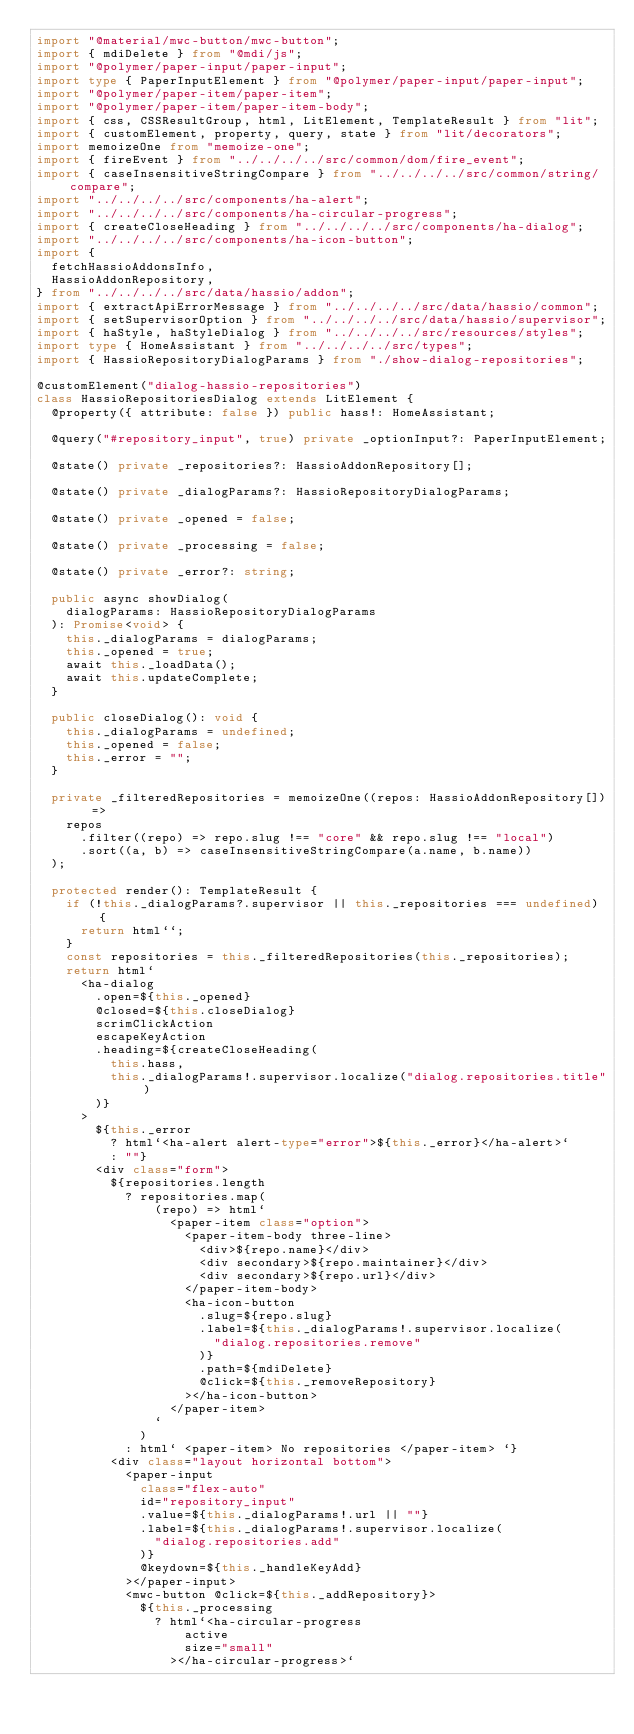Convert code to text. <code><loc_0><loc_0><loc_500><loc_500><_TypeScript_>import "@material/mwc-button/mwc-button";
import { mdiDelete } from "@mdi/js";
import "@polymer/paper-input/paper-input";
import type { PaperInputElement } from "@polymer/paper-input/paper-input";
import "@polymer/paper-item/paper-item";
import "@polymer/paper-item/paper-item-body";
import { css, CSSResultGroup, html, LitElement, TemplateResult } from "lit";
import { customElement, property, query, state } from "lit/decorators";
import memoizeOne from "memoize-one";
import { fireEvent } from "../../../../src/common/dom/fire_event";
import { caseInsensitiveStringCompare } from "../../../../src/common/string/compare";
import "../../../../src/components/ha-alert";
import "../../../../src/components/ha-circular-progress";
import { createCloseHeading } from "../../../../src/components/ha-dialog";
import "../../../../src/components/ha-icon-button";
import {
  fetchHassioAddonsInfo,
  HassioAddonRepository,
} from "../../../../src/data/hassio/addon";
import { extractApiErrorMessage } from "../../../../src/data/hassio/common";
import { setSupervisorOption } from "../../../../src/data/hassio/supervisor";
import { haStyle, haStyleDialog } from "../../../../src/resources/styles";
import type { HomeAssistant } from "../../../../src/types";
import { HassioRepositoryDialogParams } from "./show-dialog-repositories";

@customElement("dialog-hassio-repositories")
class HassioRepositoriesDialog extends LitElement {
  @property({ attribute: false }) public hass!: HomeAssistant;

  @query("#repository_input", true) private _optionInput?: PaperInputElement;

  @state() private _repositories?: HassioAddonRepository[];

  @state() private _dialogParams?: HassioRepositoryDialogParams;

  @state() private _opened = false;

  @state() private _processing = false;

  @state() private _error?: string;

  public async showDialog(
    dialogParams: HassioRepositoryDialogParams
  ): Promise<void> {
    this._dialogParams = dialogParams;
    this._opened = true;
    await this._loadData();
    await this.updateComplete;
  }

  public closeDialog(): void {
    this._dialogParams = undefined;
    this._opened = false;
    this._error = "";
  }

  private _filteredRepositories = memoizeOne((repos: HassioAddonRepository[]) =>
    repos
      .filter((repo) => repo.slug !== "core" && repo.slug !== "local")
      .sort((a, b) => caseInsensitiveStringCompare(a.name, b.name))
  );

  protected render(): TemplateResult {
    if (!this._dialogParams?.supervisor || this._repositories === undefined) {
      return html``;
    }
    const repositories = this._filteredRepositories(this._repositories);
    return html`
      <ha-dialog
        .open=${this._opened}
        @closed=${this.closeDialog}
        scrimClickAction
        escapeKeyAction
        .heading=${createCloseHeading(
          this.hass,
          this._dialogParams!.supervisor.localize("dialog.repositories.title")
        )}
      >
        ${this._error
          ? html`<ha-alert alert-type="error">${this._error}</ha-alert>`
          : ""}
        <div class="form">
          ${repositories.length
            ? repositories.map(
                (repo) => html`
                  <paper-item class="option">
                    <paper-item-body three-line>
                      <div>${repo.name}</div>
                      <div secondary>${repo.maintainer}</div>
                      <div secondary>${repo.url}</div>
                    </paper-item-body>
                    <ha-icon-button
                      .slug=${repo.slug}
                      .label=${this._dialogParams!.supervisor.localize(
                        "dialog.repositories.remove"
                      )}
                      .path=${mdiDelete}
                      @click=${this._removeRepository}
                    ></ha-icon-button>
                  </paper-item>
                `
              )
            : html` <paper-item> No repositories </paper-item> `}
          <div class="layout horizontal bottom">
            <paper-input
              class="flex-auto"
              id="repository_input"
              .value=${this._dialogParams!.url || ""}
              .label=${this._dialogParams!.supervisor.localize(
                "dialog.repositories.add"
              )}
              @keydown=${this._handleKeyAdd}
            ></paper-input>
            <mwc-button @click=${this._addRepository}>
              ${this._processing
                ? html`<ha-circular-progress
                    active
                    size="small"
                  ></ha-circular-progress>`</code> 